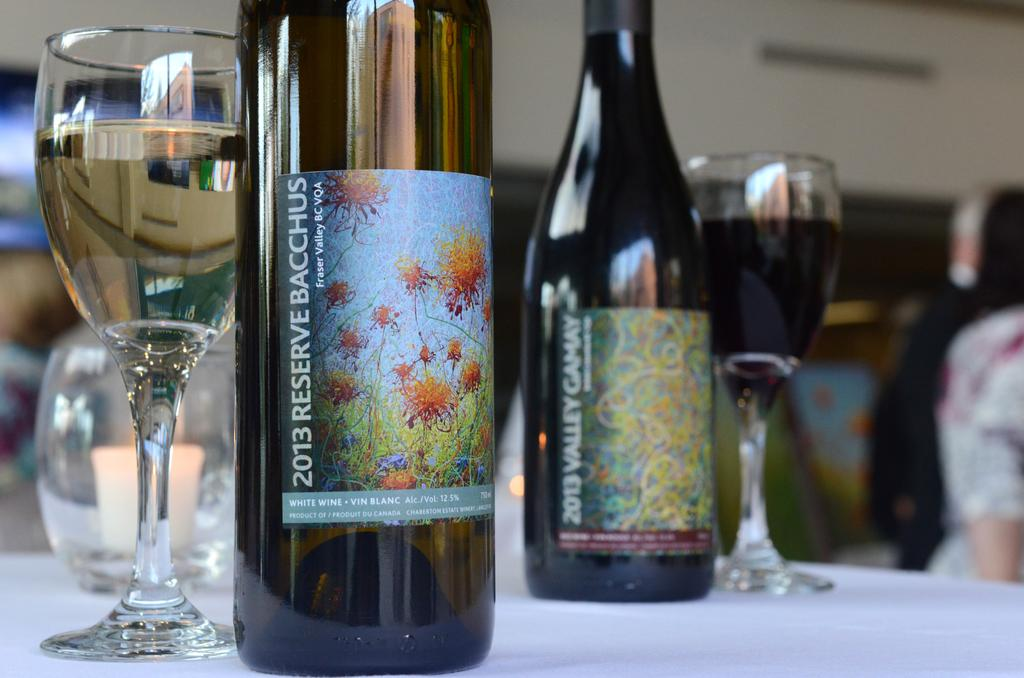What objects can be seen in the image related to beverages? There are bottles and glasses in the image. What part of a person is visible in the image? A human hand is visible in the image. What type of stamp is being used by the person in the image? There is no stamp present in the image. What nation is represented by the locket in the image? There is no locket present in the image. 